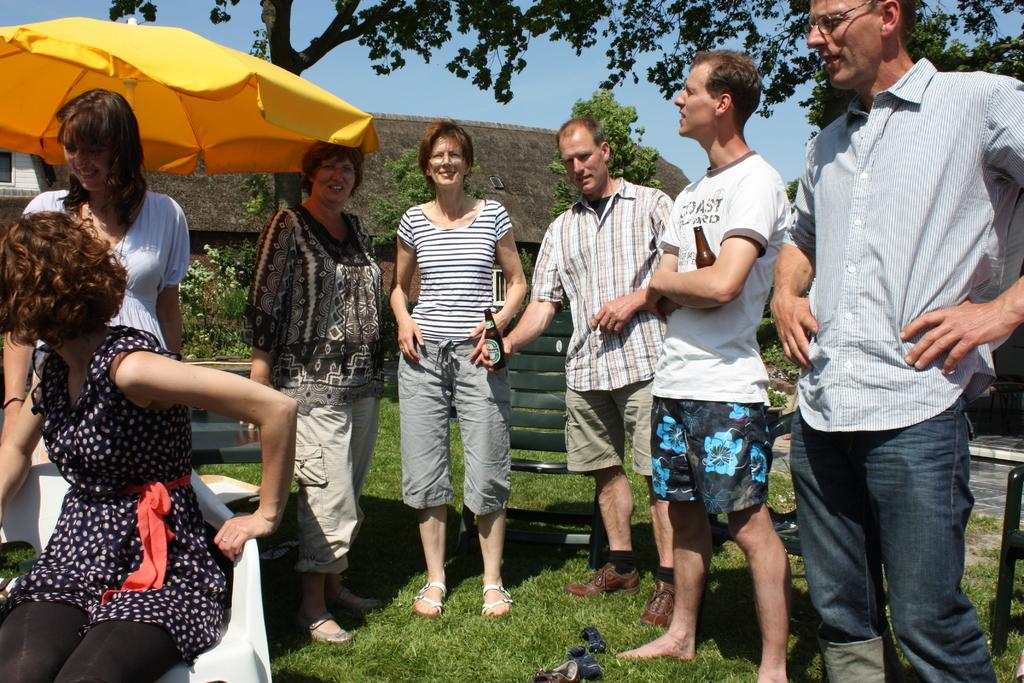What is happening in the image? There are people standing in the image. Can you describe the woman in the image? There is a woman sitting in a chair on the left side of the image. What can be seen in the background of the image? There are trees and buildings in the background of the image. How would you describe the weather in the image? The sky is clear in the image, suggesting good weather. How many spiders are crawling on the woman's chair in the image? There are no spiders visible in the image; the woman is sitting in a chair on the left side of the image. 